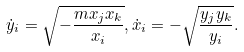<formula> <loc_0><loc_0><loc_500><loc_500>\dot { y } _ { i } = \sqrt { - \frac { m x _ { j } x _ { k } } { x _ { i } } } , \dot { x } _ { i } = - \sqrt { \frac { y _ { j } y _ { k } } { y _ { i } } } .</formula> 